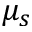Convert formula to latex. <formula><loc_0><loc_0><loc_500><loc_500>\mu _ { s }</formula> 